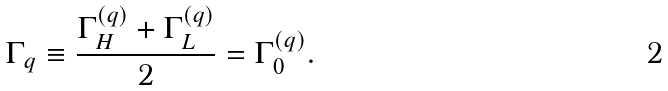Convert formula to latex. <formula><loc_0><loc_0><loc_500><loc_500>\Gamma _ { q } \equiv \frac { \Gamma ^ { ( q ) } _ { H } + \Gamma ^ { ( q ) } _ { L } } { 2 } = \Gamma ^ { ( q ) } _ { 0 } .</formula> 